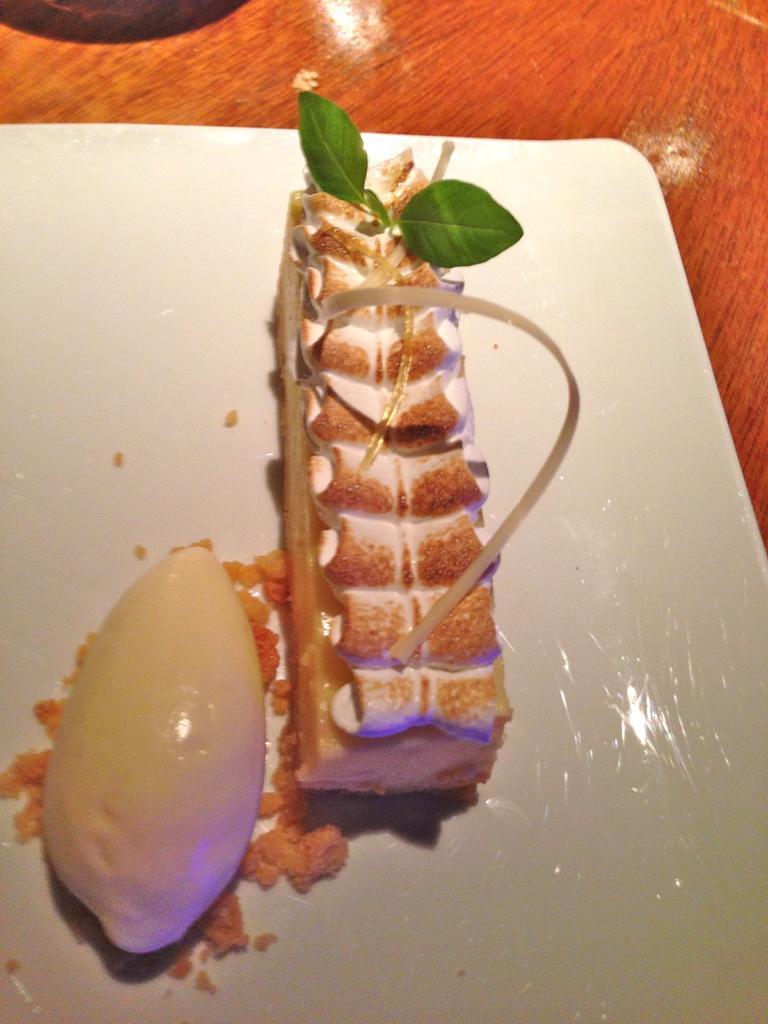How would you summarize this image in a sentence or two? This is a zoomed in picture. In the center there is a table on the top of which a platter containing some food items is placed. we can see the reflection of light on the surface of a table. 